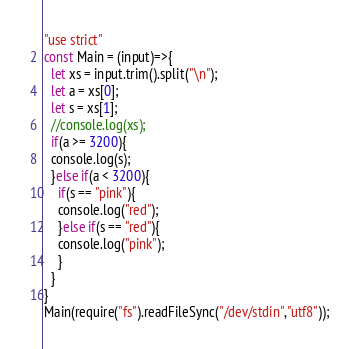<code> <loc_0><loc_0><loc_500><loc_500><_JavaScript_>"use strict"
const Main = (input)=>{
  let xs = input.trim().split("\n");
  let a = xs[0];
  let s = xs[1];
  //console.log(xs);
  if(a >= 3200){
  console.log(s);  
  }else if(a < 3200){
    if(s == "pink"){
    console.log("red");
    }else if(s == "red"){
    console.log("pink");
    }
  }  
}
Main(require("fs").readFileSync("/dev/stdin","utf8"));</code> 